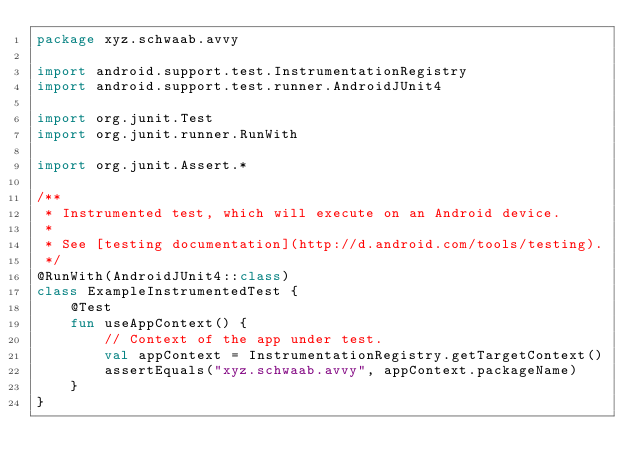<code> <loc_0><loc_0><loc_500><loc_500><_Kotlin_>package xyz.schwaab.avvy

import android.support.test.InstrumentationRegistry
import android.support.test.runner.AndroidJUnit4

import org.junit.Test
import org.junit.runner.RunWith

import org.junit.Assert.*

/**
 * Instrumented test, which will execute on an Android device.
 *
 * See [testing documentation](http://d.android.com/tools/testing).
 */
@RunWith(AndroidJUnit4::class)
class ExampleInstrumentedTest {
    @Test
    fun useAppContext() {
        // Context of the app under test.
        val appContext = InstrumentationRegistry.getTargetContext()
        assertEquals("xyz.schwaab.avvy", appContext.packageName)
    }
}
</code> 